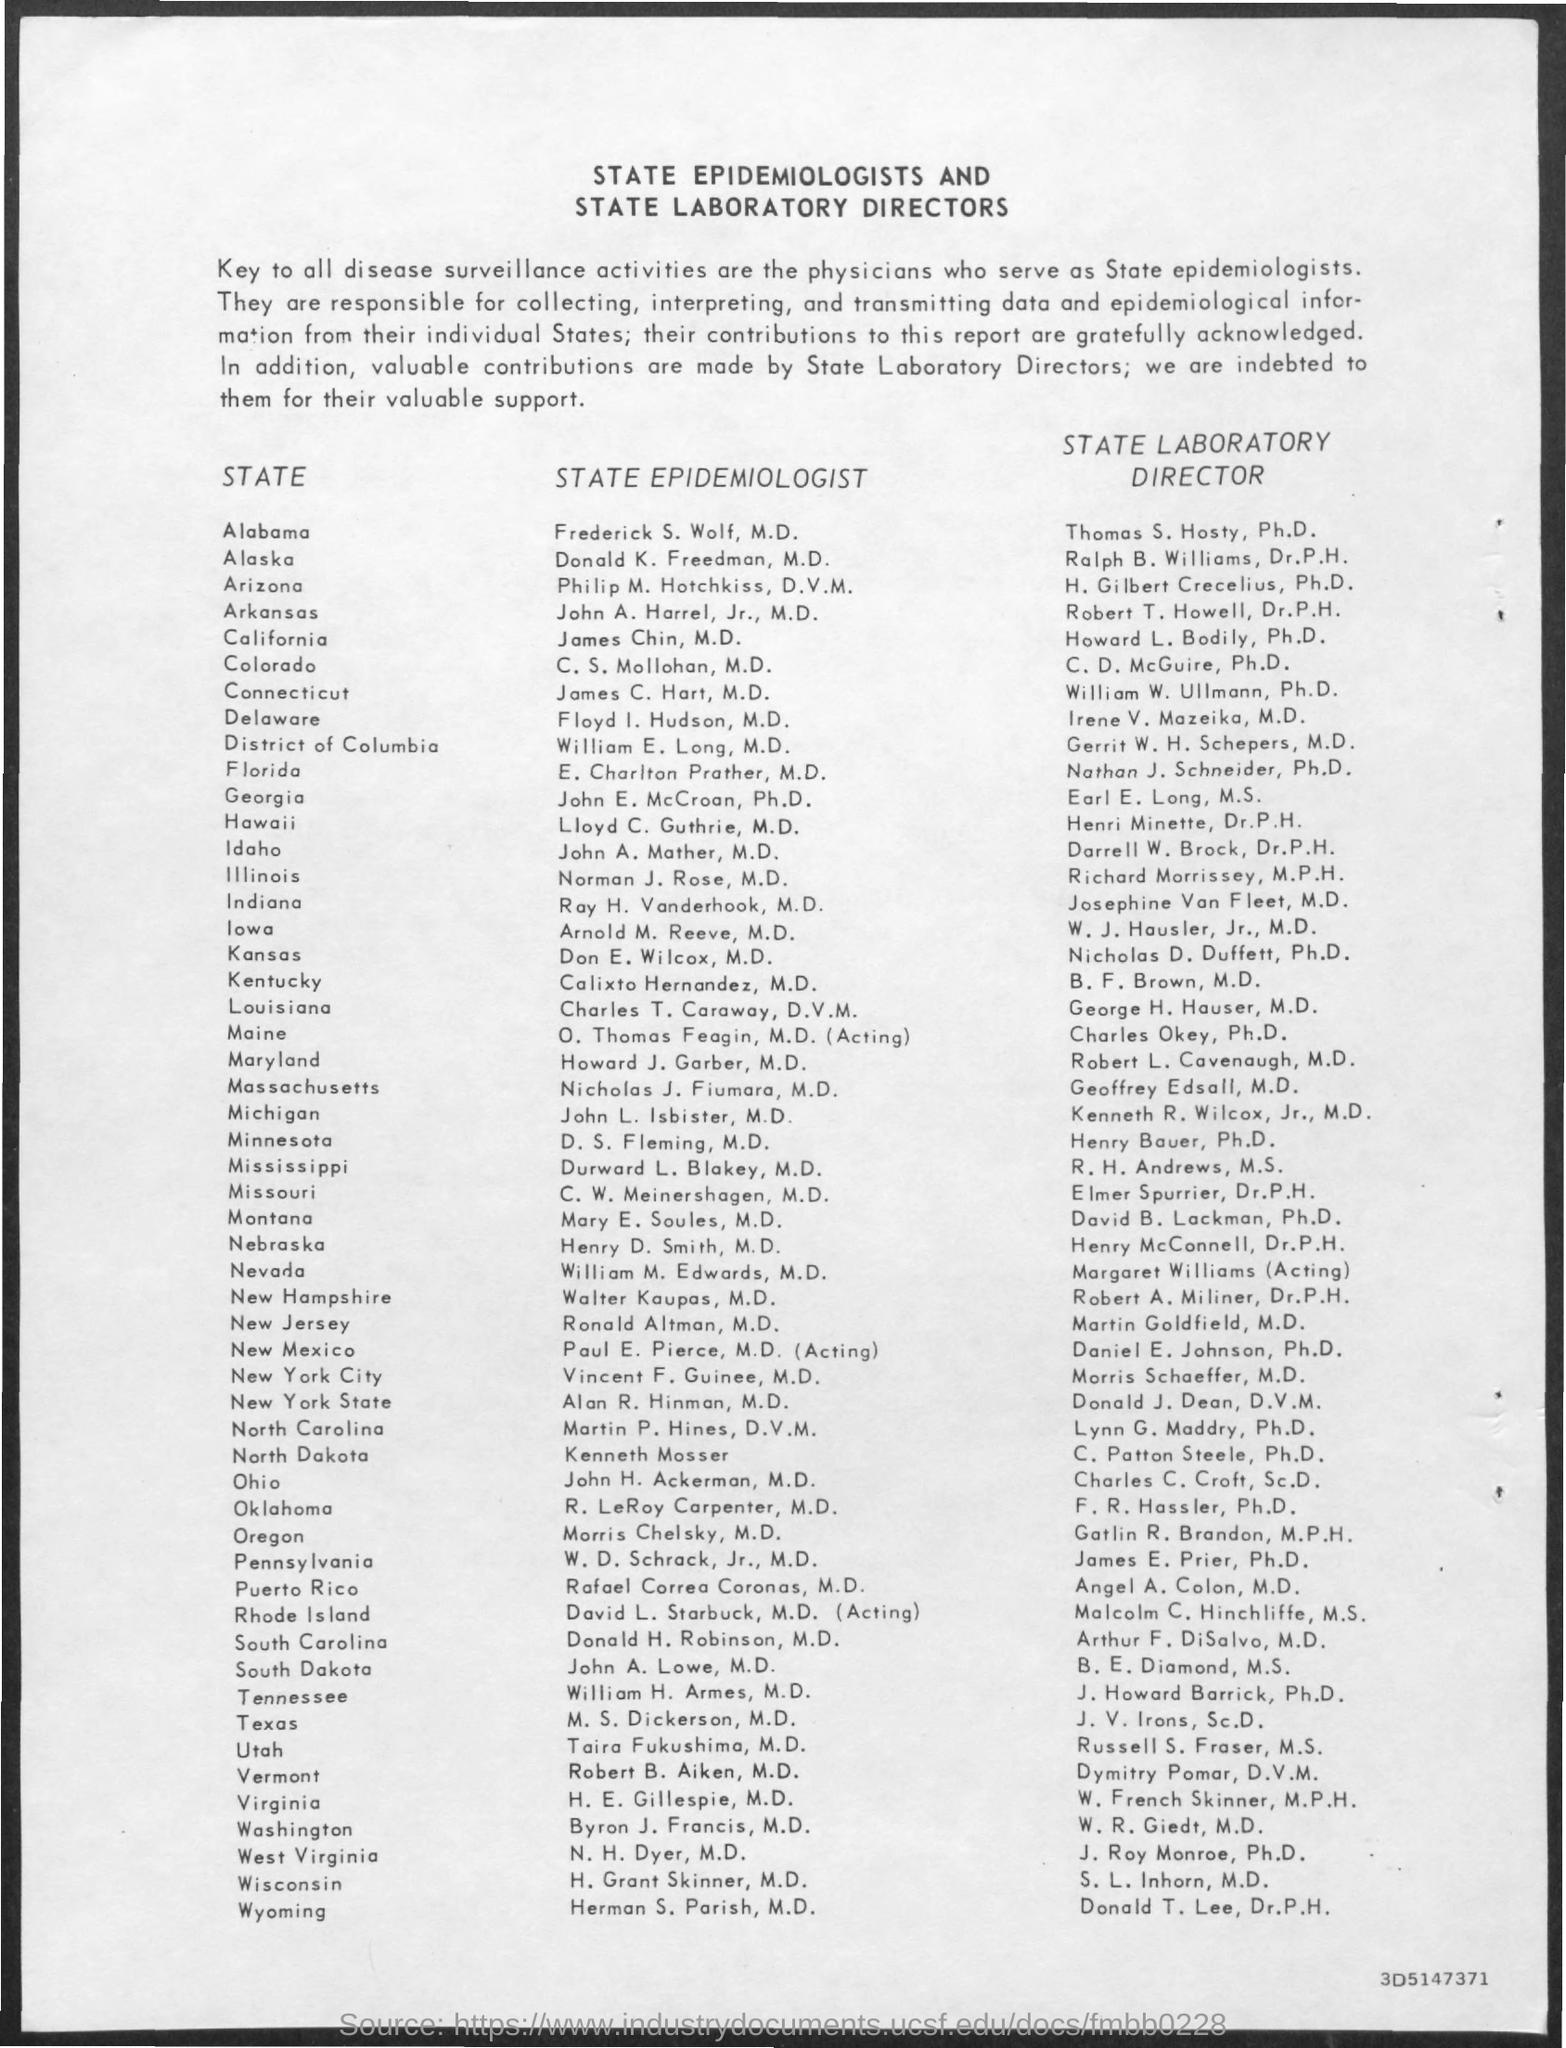Mention a couple of crucial points in this snapshot. The state epidemiologist of Alabama is Frederick S. Wolf. Physicians who serve as state epidemiologists are the key to all disease surveillance activities. Thomas S. Hosty, Ph.D., is the state laboratory director of Alabama. 